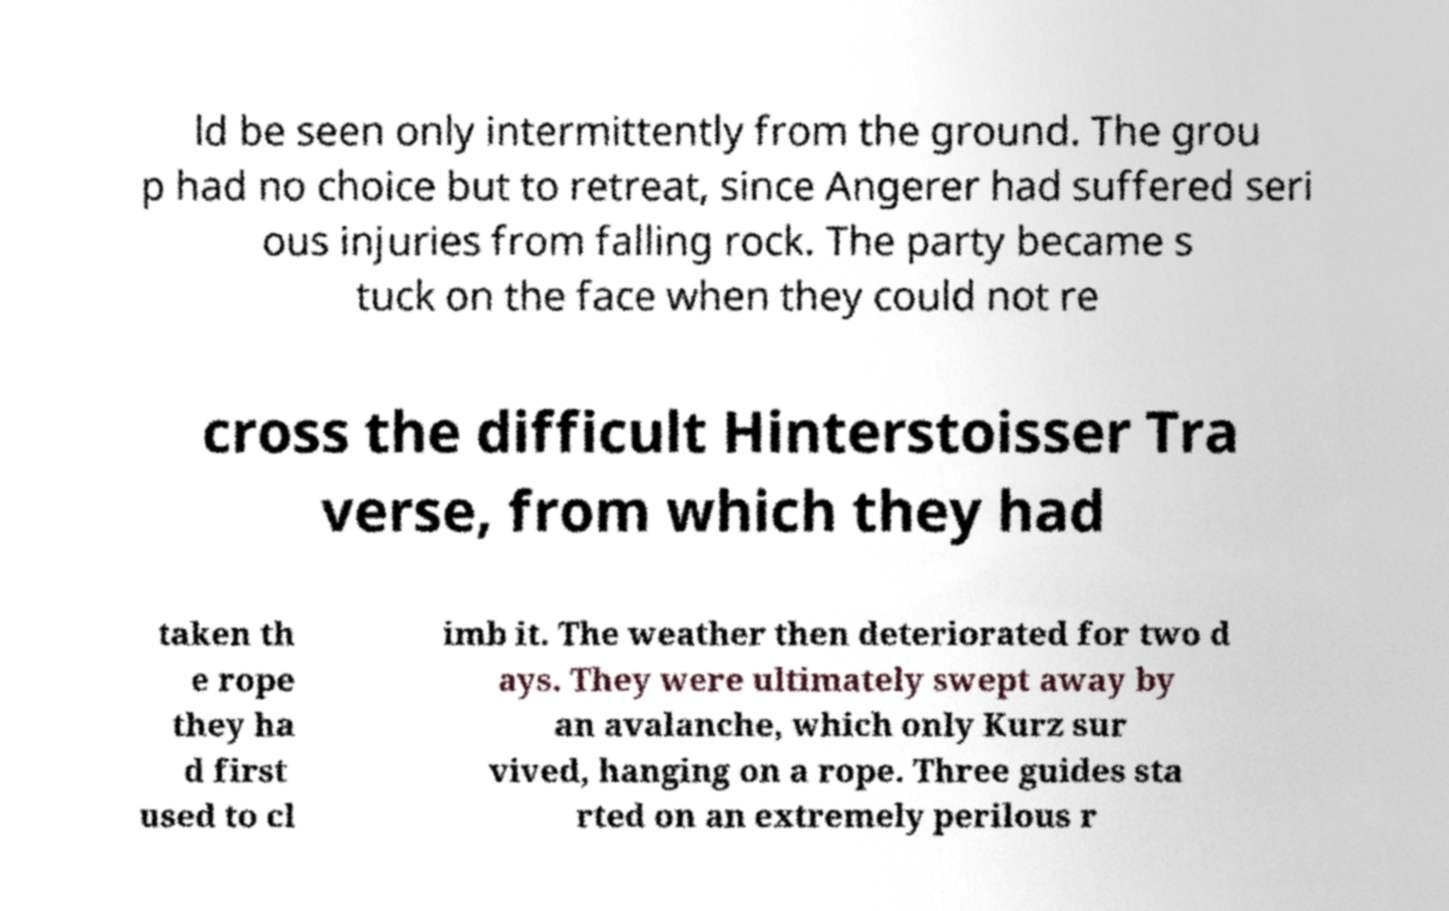I need the written content from this picture converted into text. Can you do that? ld be seen only intermittently from the ground. The grou p had no choice but to retreat, since Angerer had suffered seri ous injuries from falling rock. The party became s tuck on the face when they could not re cross the difficult Hinterstoisser Tra verse, from which they had taken th e rope they ha d first used to cl imb it. The weather then deteriorated for two d ays. They were ultimately swept away by an avalanche, which only Kurz sur vived, hanging on a rope. Three guides sta rted on an extremely perilous r 